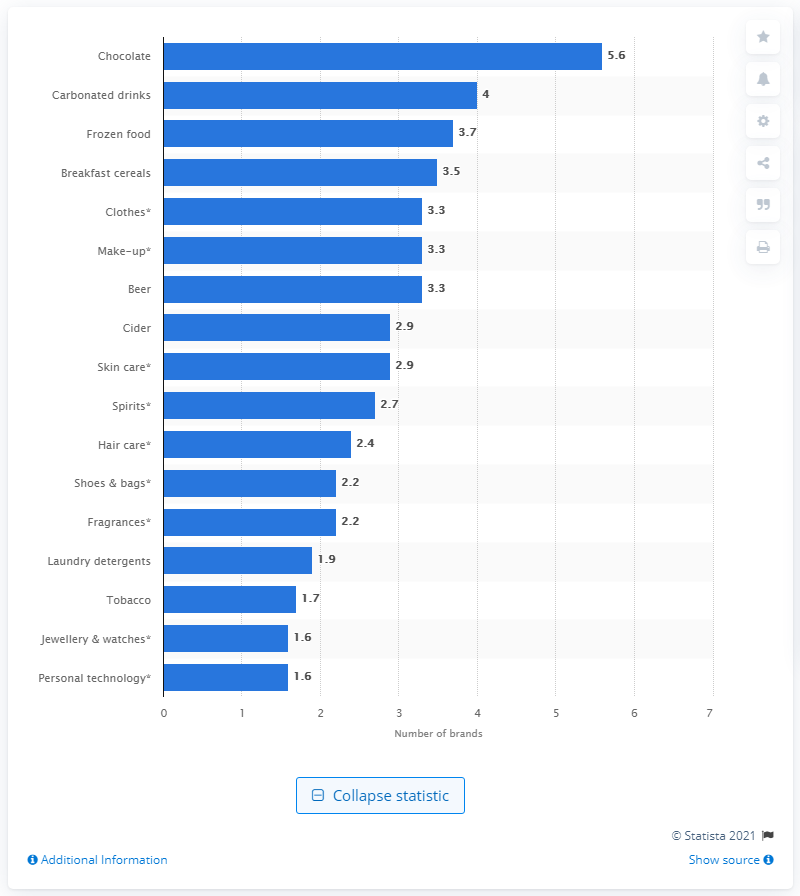Highlight a few significant elements in this photo. Consumers bought an average of 5.6 different brands of chocolate per month. 